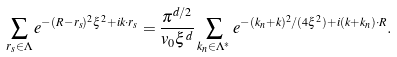<formula> <loc_0><loc_0><loc_500><loc_500>\sum _ { { r } _ { s } \in \Lambda } e ^ { - ( { R } - { r } _ { s } ) ^ { 2 } \xi ^ { 2 } + i { k } \cdot { r } _ { s } } = \frac { \pi ^ { d / 2 } } { v _ { 0 } \xi ^ { d } } \sum _ { { k } _ { n } \in \Lambda ^ { * } } e ^ { - ( { k } _ { n } + { k } ) ^ { 2 } / ( 4 \xi ^ { 2 } ) + i ( { k } + { k } _ { n } ) \cdot { R } } .</formula> 